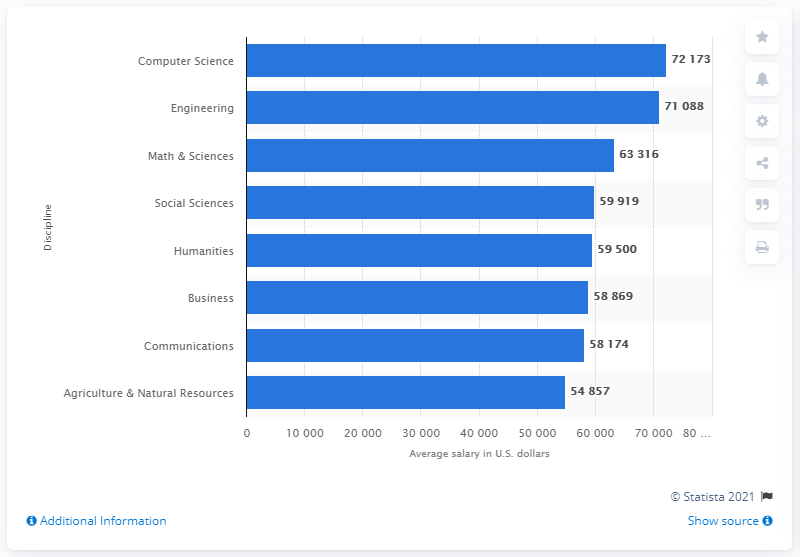Point out several critical features in this image. According to predictions for 2021, earning a degree in Computer Science is expected to result in the highest salary in the United States. A Bachelor's degree in Engineering is a field of study that focuses on the application of scientific, economic, social, and practical knowledge to design, develop, and improve systems, structures, and technology. 